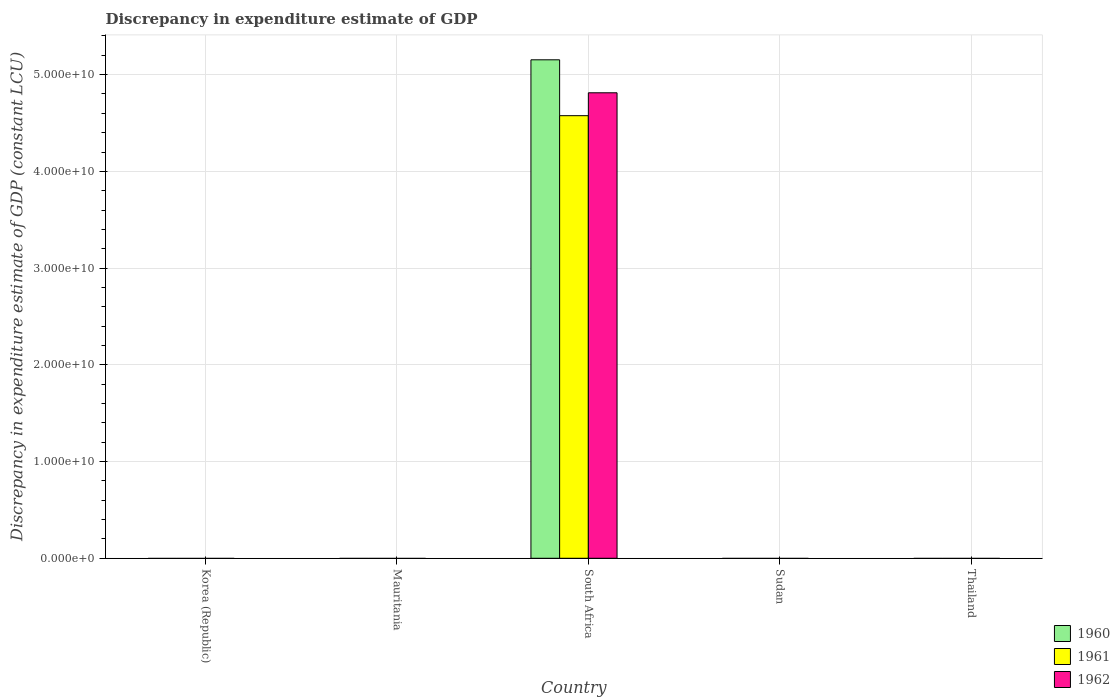Are the number of bars per tick equal to the number of legend labels?
Provide a succinct answer. No. How many bars are there on the 2nd tick from the right?
Your response must be concise. 0. What is the label of the 3rd group of bars from the left?
Your answer should be compact. South Africa. What is the discrepancy in expenditure estimate of GDP in 1961 in Sudan?
Provide a succinct answer. 0. Across all countries, what is the maximum discrepancy in expenditure estimate of GDP in 1962?
Your answer should be compact. 4.81e+1. Across all countries, what is the minimum discrepancy in expenditure estimate of GDP in 1961?
Your response must be concise. 0. In which country was the discrepancy in expenditure estimate of GDP in 1962 maximum?
Your response must be concise. South Africa. What is the total discrepancy in expenditure estimate of GDP in 1961 in the graph?
Your answer should be compact. 4.58e+1. What is the average discrepancy in expenditure estimate of GDP in 1960 per country?
Your response must be concise. 1.03e+1. What is the difference between the discrepancy in expenditure estimate of GDP of/in 1960 and discrepancy in expenditure estimate of GDP of/in 1961 in South Africa?
Your answer should be compact. 5.78e+09. In how many countries, is the discrepancy in expenditure estimate of GDP in 1962 greater than 38000000000 LCU?
Keep it short and to the point. 1. What is the difference between the highest and the lowest discrepancy in expenditure estimate of GDP in 1960?
Keep it short and to the point. 5.15e+1. Is it the case that in every country, the sum of the discrepancy in expenditure estimate of GDP in 1961 and discrepancy in expenditure estimate of GDP in 1960 is greater than the discrepancy in expenditure estimate of GDP in 1962?
Provide a succinct answer. No. How many countries are there in the graph?
Ensure brevity in your answer.  5. What is the difference between two consecutive major ticks on the Y-axis?
Provide a short and direct response. 1.00e+1. Are the values on the major ticks of Y-axis written in scientific E-notation?
Give a very brief answer. Yes. Where does the legend appear in the graph?
Provide a succinct answer. Bottom right. How are the legend labels stacked?
Your answer should be compact. Vertical. What is the title of the graph?
Your answer should be very brief. Discrepancy in expenditure estimate of GDP. Does "1966" appear as one of the legend labels in the graph?
Offer a very short reply. No. What is the label or title of the Y-axis?
Your response must be concise. Discrepancy in expenditure estimate of GDP (constant LCU). What is the Discrepancy in expenditure estimate of GDP (constant LCU) of 1962 in Korea (Republic)?
Offer a terse response. 0. What is the Discrepancy in expenditure estimate of GDP (constant LCU) of 1960 in Mauritania?
Provide a succinct answer. 0. What is the Discrepancy in expenditure estimate of GDP (constant LCU) of 1962 in Mauritania?
Offer a terse response. 0. What is the Discrepancy in expenditure estimate of GDP (constant LCU) of 1960 in South Africa?
Your response must be concise. 5.15e+1. What is the Discrepancy in expenditure estimate of GDP (constant LCU) of 1961 in South Africa?
Give a very brief answer. 4.58e+1. What is the Discrepancy in expenditure estimate of GDP (constant LCU) in 1962 in South Africa?
Give a very brief answer. 4.81e+1. What is the Discrepancy in expenditure estimate of GDP (constant LCU) in 1960 in Sudan?
Your answer should be very brief. 0. What is the Discrepancy in expenditure estimate of GDP (constant LCU) in 1962 in Sudan?
Your answer should be very brief. 0. Across all countries, what is the maximum Discrepancy in expenditure estimate of GDP (constant LCU) of 1960?
Offer a very short reply. 5.15e+1. Across all countries, what is the maximum Discrepancy in expenditure estimate of GDP (constant LCU) of 1961?
Your response must be concise. 4.58e+1. Across all countries, what is the maximum Discrepancy in expenditure estimate of GDP (constant LCU) of 1962?
Provide a succinct answer. 4.81e+1. What is the total Discrepancy in expenditure estimate of GDP (constant LCU) in 1960 in the graph?
Make the answer very short. 5.15e+1. What is the total Discrepancy in expenditure estimate of GDP (constant LCU) of 1961 in the graph?
Your answer should be very brief. 4.58e+1. What is the total Discrepancy in expenditure estimate of GDP (constant LCU) in 1962 in the graph?
Provide a succinct answer. 4.81e+1. What is the average Discrepancy in expenditure estimate of GDP (constant LCU) in 1960 per country?
Make the answer very short. 1.03e+1. What is the average Discrepancy in expenditure estimate of GDP (constant LCU) in 1961 per country?
Your response must be concise. 9.15e+09. What is the average Discrepancy in expenditure estimate of GDP (constant LCU) of 1962 per country?
Offer a very short reply. 9.62e+09. What is the difference between the Discrepancy in expenditure estimate of GDP (constant LCU) of 1960 and Discrepancy in expenditure estimate of GDP (constant LCU) of 1961 in South Africa?
Offer a very short reply. 5.78e+09. What is the difference between the Discrepancy in expenditure estimate of GDP (constant LCU) in 1960 and Discrepancy in expenditure estimate of GDP (constant LCU) in 1962 in South Africa?
Give a very brief answer. 3.41e+09. What is the difference between the Discrepancy in expenditure estimate of GDP (constant LCU) in 1961 and Discrepancy in expenditure estimate of GDP (constant LCU) in 1962 in South Africa?
Provide a short and direct response. -2.37e+09. What is the difference between the highest and the lowest Discrepancy in expenditure estimate of GDP (constant LCU) of 1960?
Provide a succinct answer. 5.15e+1. What is the difference between the highest and the lowest Discrepancy in expenditure estimate of GDP (constant LCU) of 1961?
Provide a succinct answer. 4.58e+1. What is the difference between the highest and the lowest Discrepancy in expenditure estimate of GDP (constant LCU) in 1962?
Provide a short and direct response. 4.81e+1. 